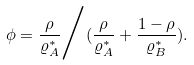<formula> <loc_0><loc_0><loc_500><loc_500>\phi = \frac { \rho } { \varrho _ { A } ^ { * } } \Big / ( \frac { \rho } { \varrho _ { A } ^ { * } } + \frac { 1 - \rho } { \varrho _ { B } ^ { * } } ) .</formula> 